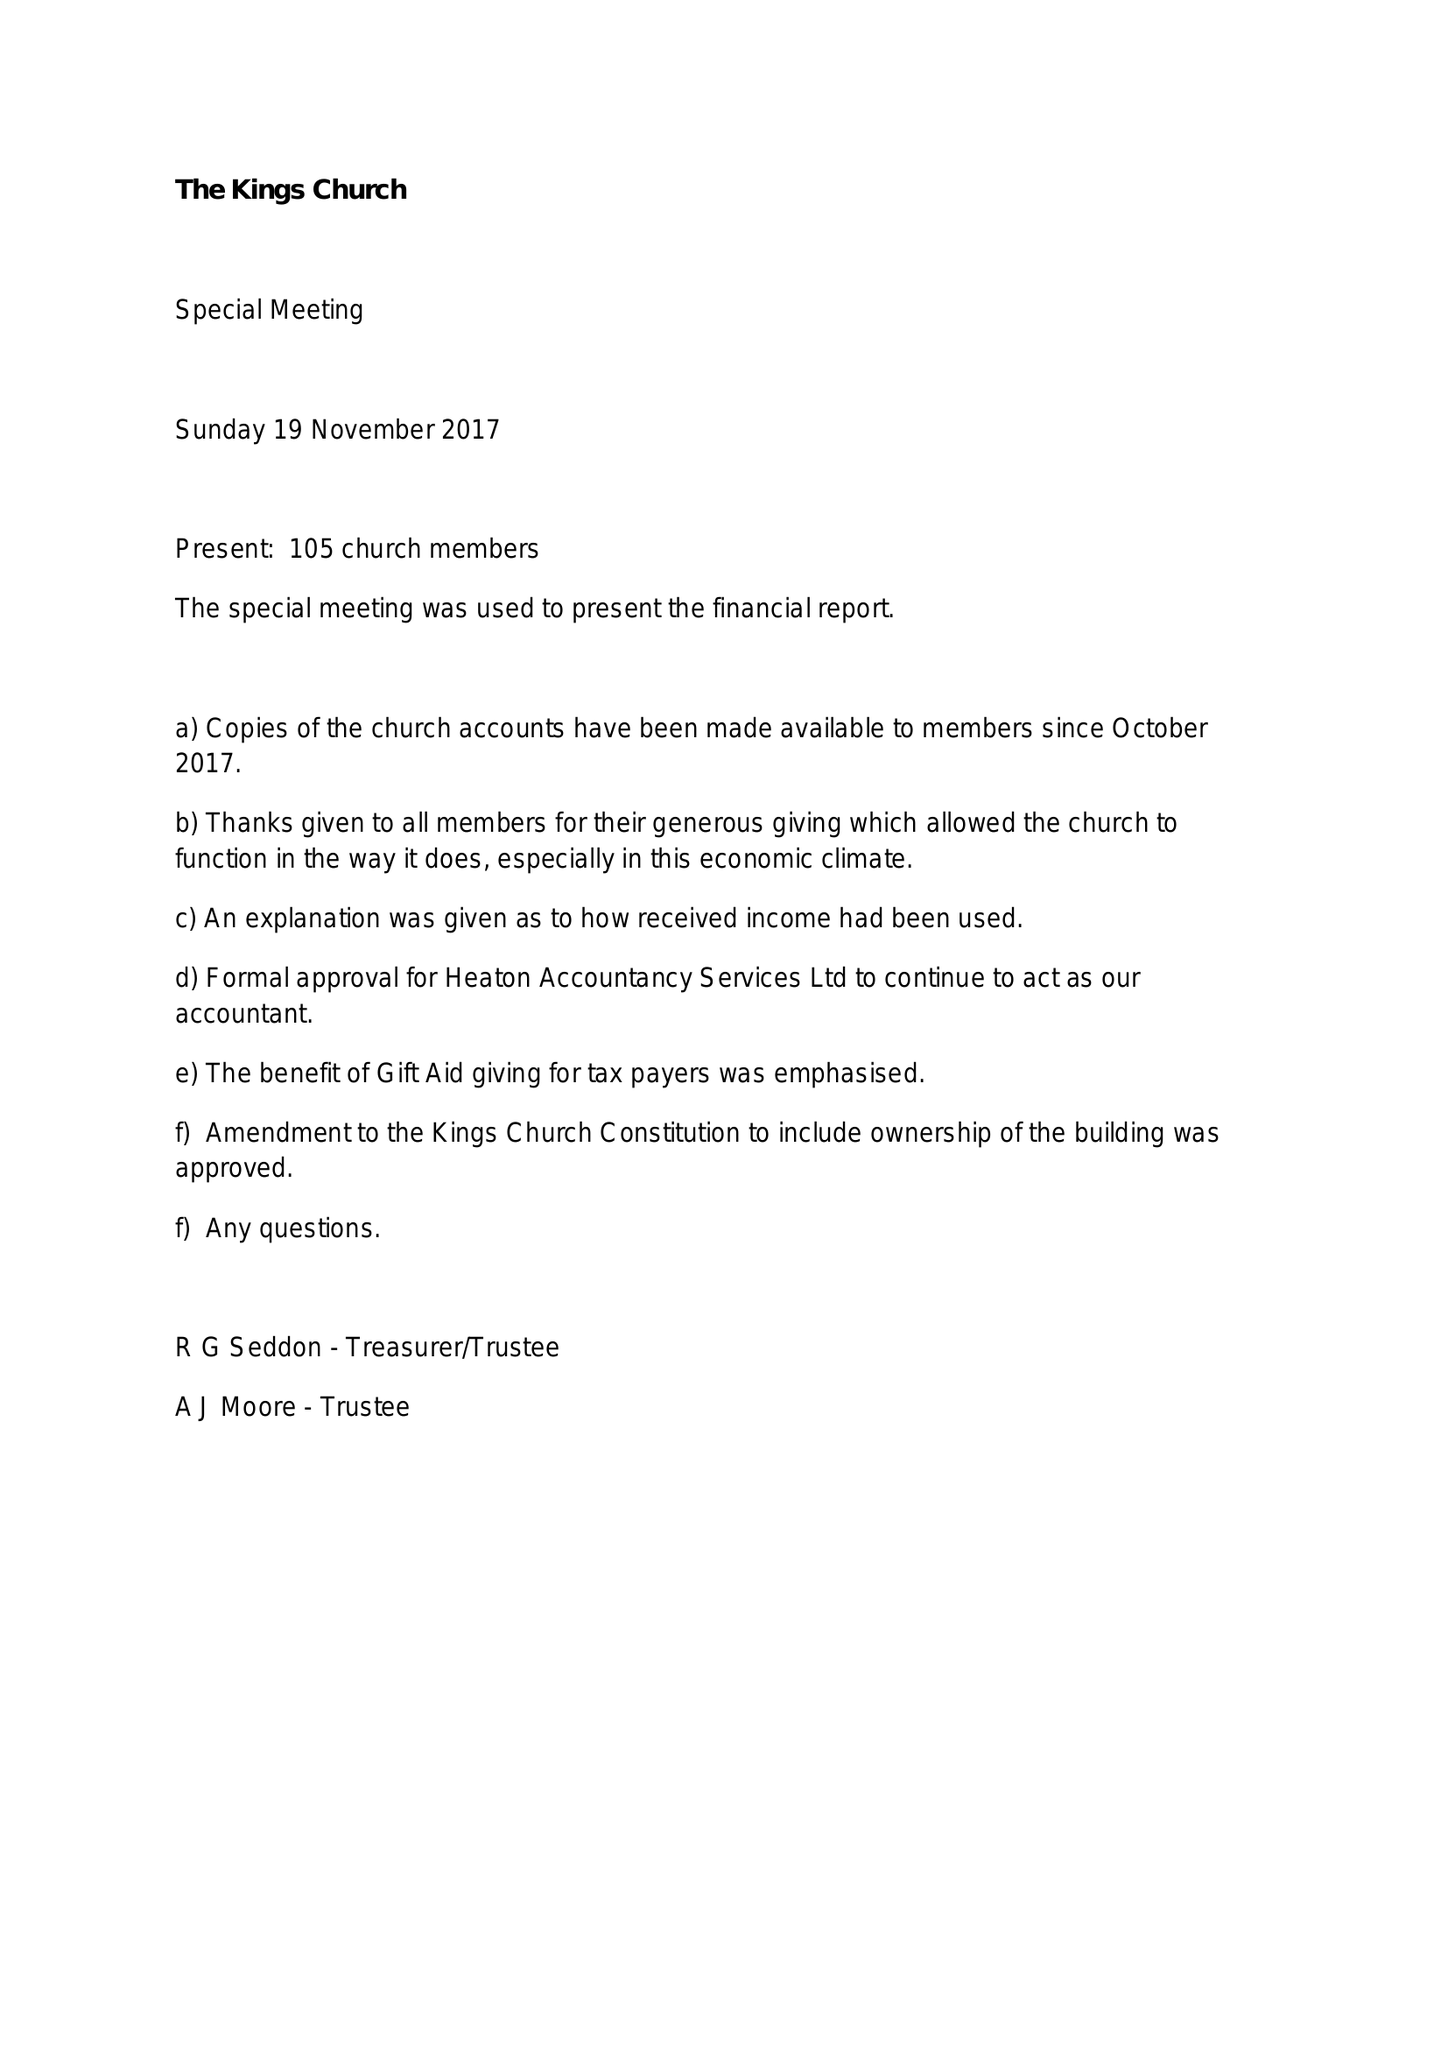What is the value for the income_annually_in_british_pounds?
Answer the question using a single word or phrase. 109049.00 